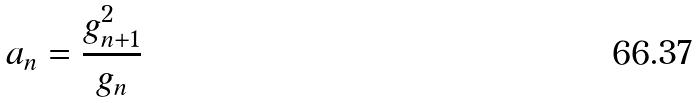<formula> <loc_0><loc_0><loc_500><loc_500>a _ { n } = \frac { g _ { n + 1 } ^ { 2 } } { g _ { n } }</formula> 